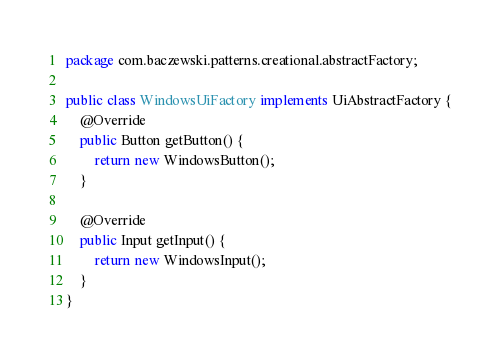Convert code to text. <code><loc_0><loc_0><loc_500><loc_500><_Java_>package com.baczewski.patterns.creational.abstractFactory;

public class WindowsUiFactory implements UiAbstractFactory {
    @Override
    public Button getButton() {
        return new WindowsButton();
    }

    @Override
    public Input getInput() {
        return new WindowsInput();
    }
}
</code> 